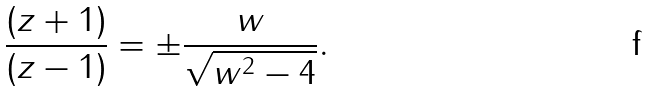Convert formula to latex. <formula><loc_0><loc_0><loc_500><loc_500>\frac { ( z + 1 ) } { ( z - 1 ) } = \pm \frac { w } { \sqrt { w ^ { 2 } - 4 } } .</formula> 